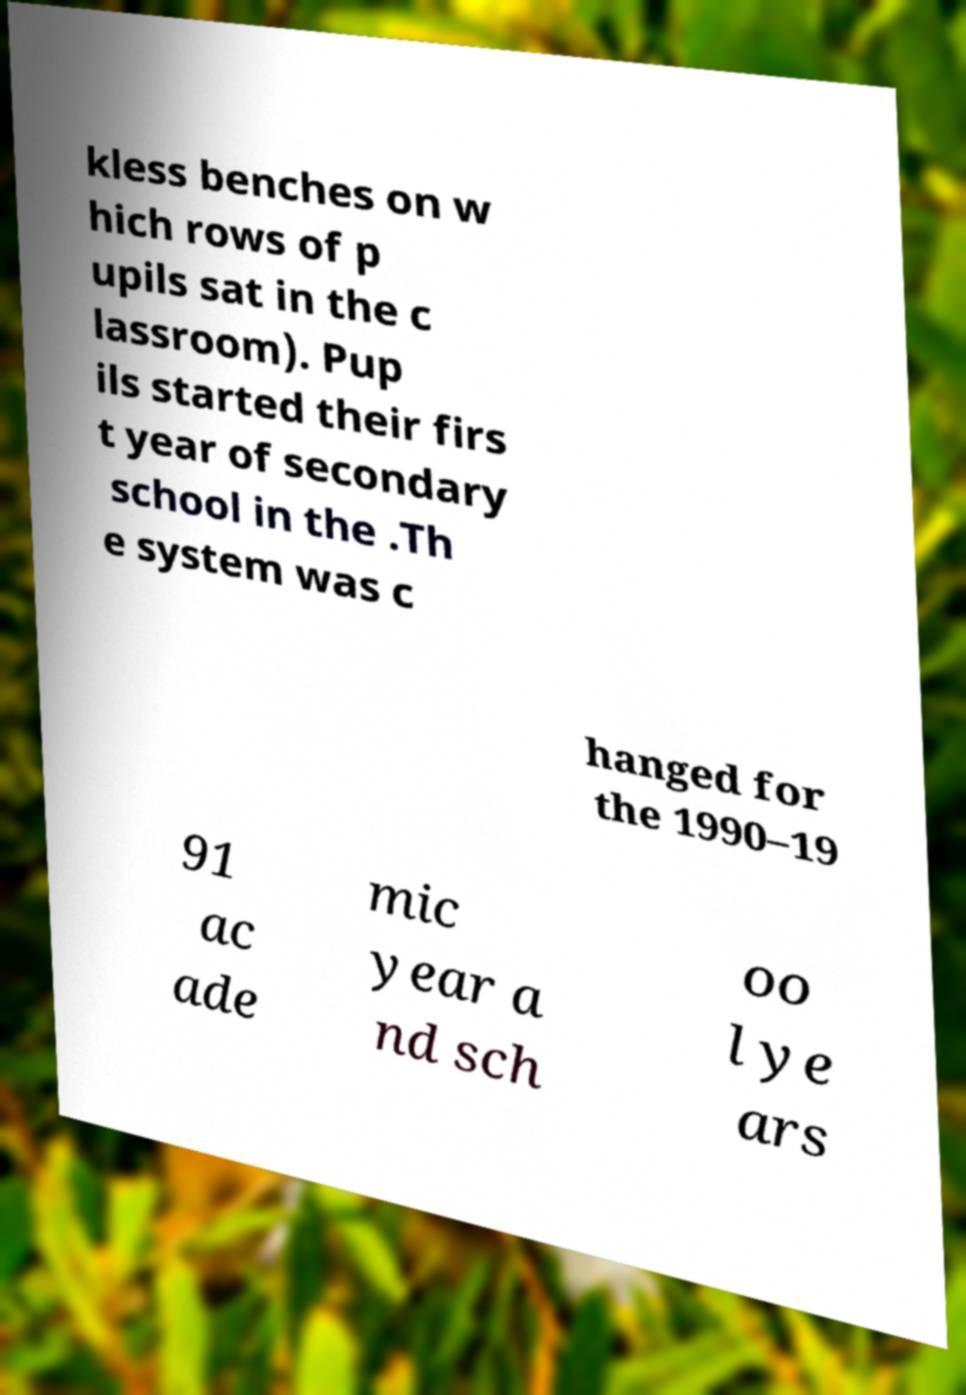Please identify and transcribe the text found in this image. kless benches on w hich rows of p upils sat in the c lassroom). Pup ils started their firs t year of secondary school in the .Th e system was c hanged for the 1990–19 91 ac ade mic year a nd sch oo l ye ars 